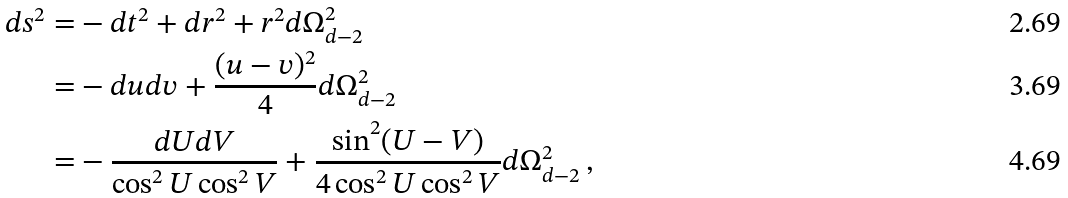<formula> <loc_0><loc_0><loc_500><loc_500>d s ^ { 2 } = & - d t ^ { 2 } + d r ^ { 2 } + r ^ { 2 } d \Omega _ { d - 2 } ^ { 2 } \\ = & - d u d v + \frac { ( u - v ) ^ { 2 } } { 4 } d \Omega _ { d - 2 } ^ { 2 } \\ = & - \frac { d U d V } { \cos ^ { 2 } U \cos ^ { 2 } V } + \frac { \sin ^ { 2 } ( U - V ) } { 4 \cos ^ { 2 } U \cos ^ { 2 } V } d \Omega _ { d - 2 } ^ { 2 } \, ,</formula> 